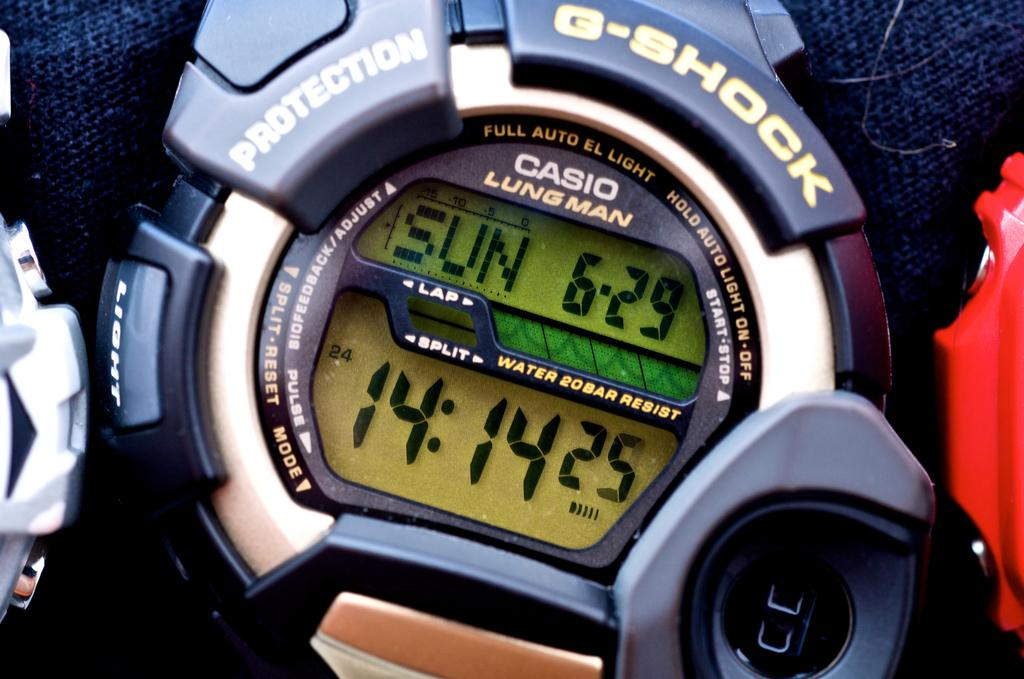<image>
Present a compact description of the photo's key features. A G-Shock stopwatch with the time set at "14:14". 